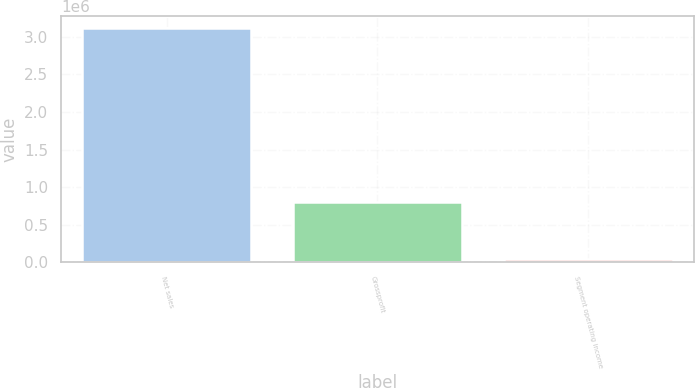Convert chart. <chart><loc_0><loc_0><loc_500><loc_500><bar_chart><fcel>Net sales<fcel>Grossprofit<fcel>Segment operating income<nl><fcel>3.12243e+06<fcel>798558<fcel>45002<nl></chart> 